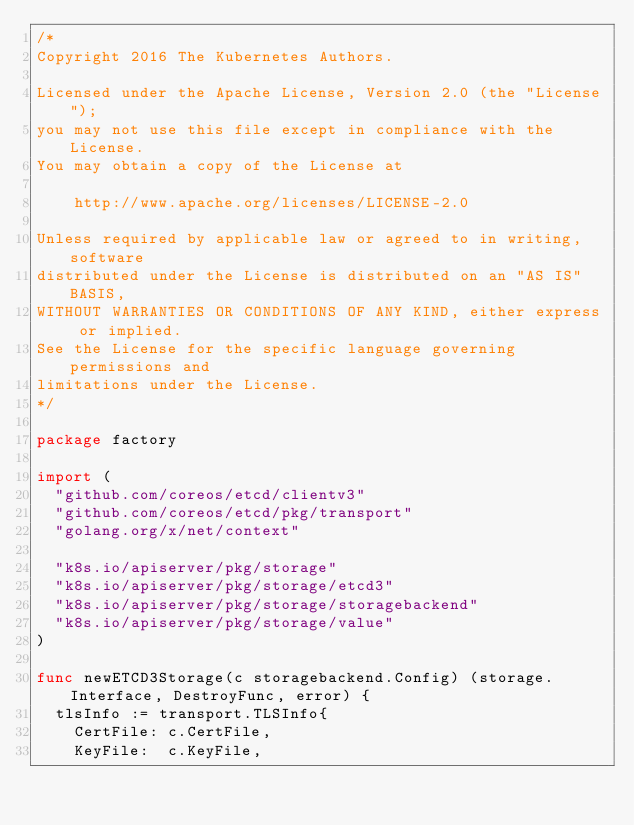Convert code to text. <code><loc_0><loc_0><loc_500><loc_500><_Go_>/*
Copyright 2016 The Kubernetes Authors.

Licensed under the Apache License, Version 2.0 (the "License");
you may not use this file except in compliance with the License.
You may obtain a copy of the License at

    http://www.apache.org/licenses/LICENSE-2.0

Unless required by applicable law or agreed to in writing, software
distributed under the License is distributed on an "AS IS" BASIS,
WITHOUT WARRANTIES OR CONDITIONS OF ANY KIND, either express or implied.
See the License for the specific language governing permissions and
limitations under the License.
*/

package factory

import (
	"github.com/coreos/etcd/clientv3"
	"github.com/coreos/etcd/pkg/transport"
	"golang.org/x/net/context"

	"k8s.io/apiserver/pkg/storage"
	"k8s.io/apiserver/pkg/storage/etcd3"
	"k8s.io/apiserver/pkg/storage/storagebackend"
	"k8s.io/apiserver/pkg/storage/value"
)

func newETCD3Storage(c storagebackend.Config) (storage.Interface, DestroyFunc, error) {
	tlsInfo := transport.TLSInfo{
		CertFile: c.CertFile,
		KeyFile:  c.KeyFile,</code> 